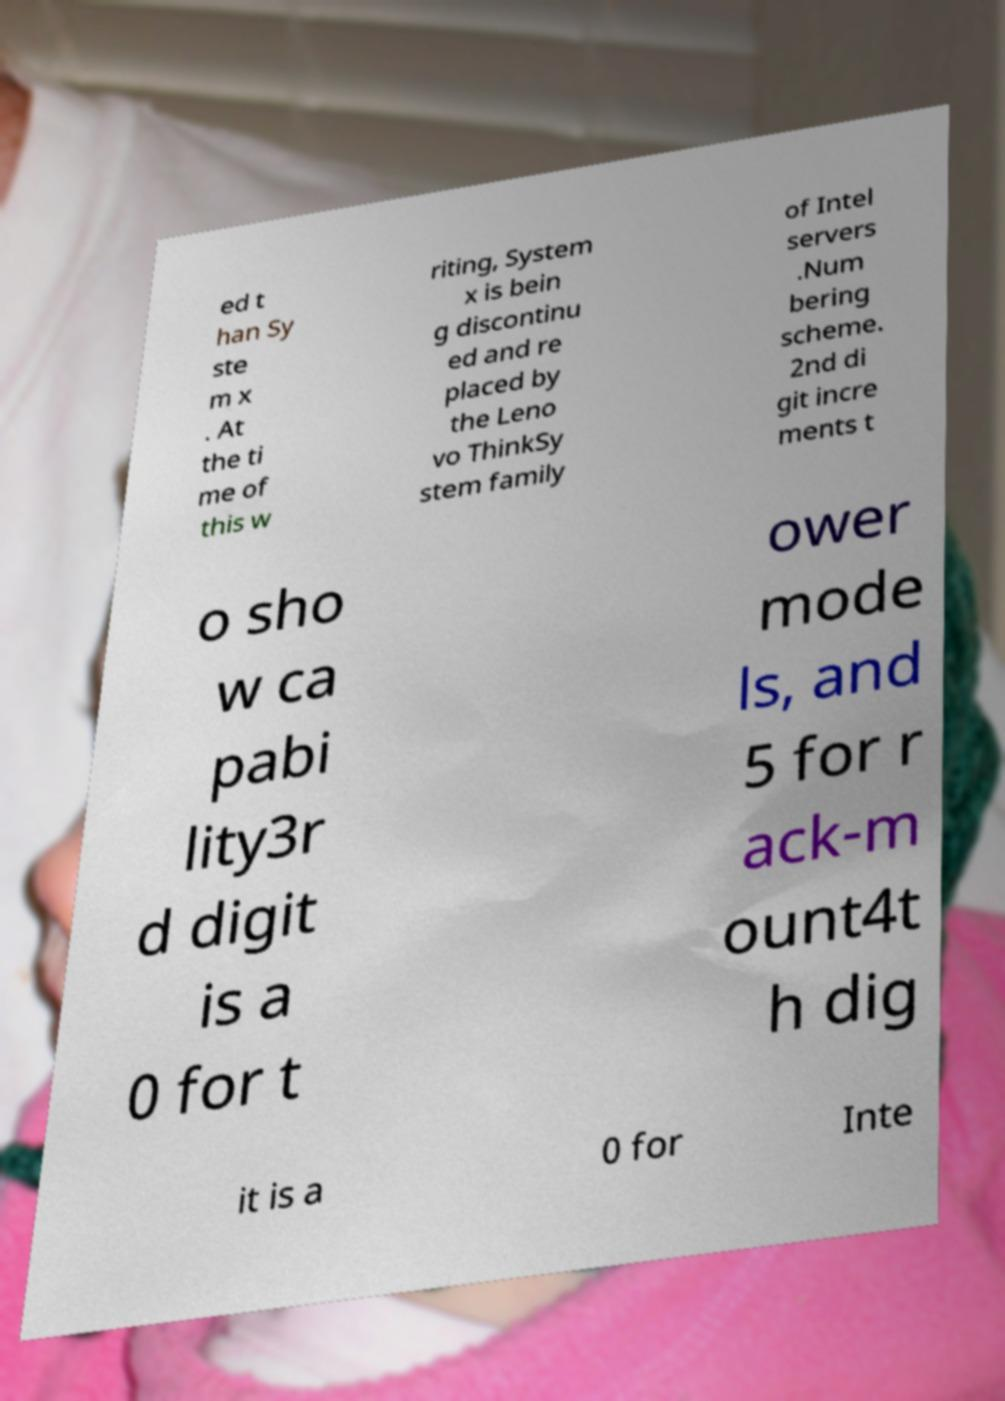What messages or text are displayed in this image? I need them in a readable, typed format. ed t han Sy ste m x . At the ti me of this w riting, System x is bein g discontinu ed and re placed by the Leno vo ThinkSy stem family of Intel servers .Num bering scheme. 2nd di git incre ments t o sho w ca pabi lity3r d digit is a 0 for t ower mode ls, and 5 for r ack-m ount4t h dig it is a 0 for Inte 